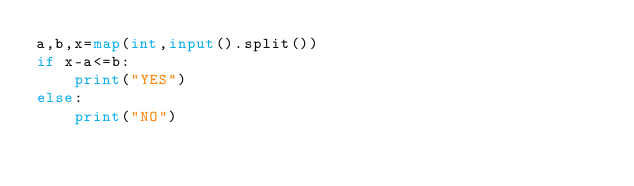Convert code to text. <code><loc_0><loc_0><loc_500><loc_500><_Python_>a,b,x=map(int,input().split())
if x-a<=b:
    print("YES")
else:
    print("NO")
</code> 